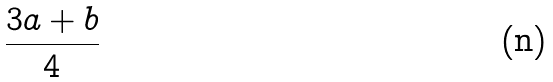Convert formula to latex. <formula><loc_0><loc_0><loc_500><loc_500>\frac { 3 a + b } { 4 }</formula> 